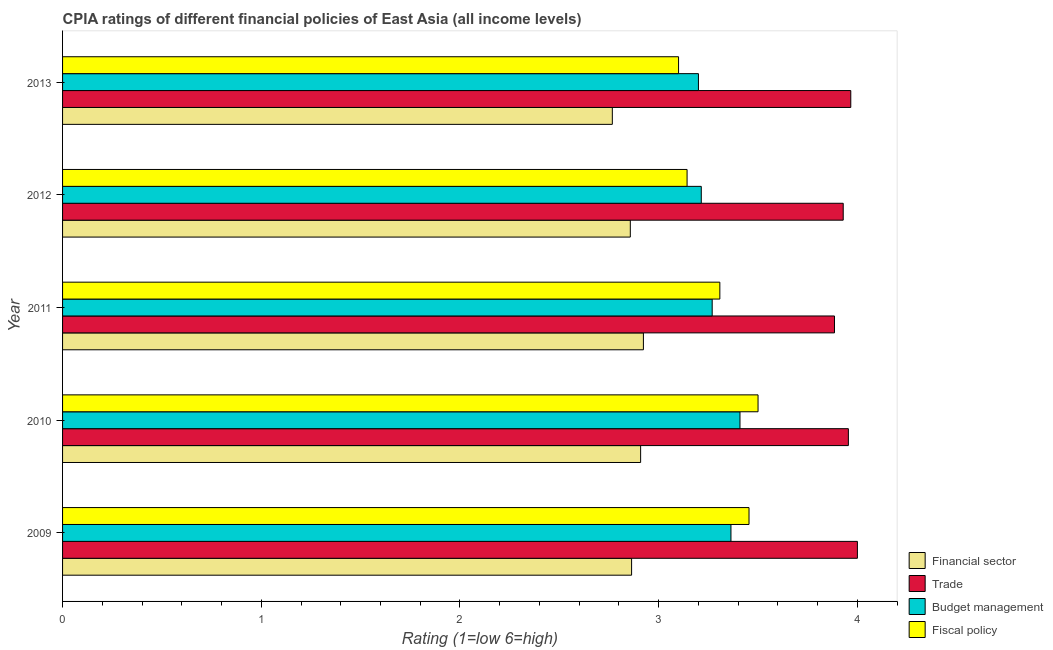How many different coloured bars are there?
Your response must be concise. 4. How many groups of bars are there?
Provide a short and direct response. 5. Are the number of bars on each tick of the Y-axis equal?
Your answer should be compact. Yes. How many bars are there on the 3rd tick from the top?
Your answer should be compact. 4. How many bars are there on the 5th tick from the bottom?
Provide a short and direct response. 4. In how many cases, is the number of bars for a given year not equal to the number of legend labels?
Keep it short and to the point. 0. What is the cpia rating of fiscal policy in 2013?
Make the answer very short. 3.1. Across all years, what is the maximum cpia rating of budget management?
Provide a short and direct response. 3.41. Across all years, what is the minimum cpia rating of trade?
Keep it short and to the point. 3.88. In which year was the cpia rating of fiscal policy maximum?
Ensure brevity in your answer.  2010. In which year was the cpia rating of trade minimum?
Provide a short and direct response. 2011. What is the total cpia rating of financial sector in the graph?
Offer a very short reply. 14.32. What is the difference between the cpia rating of financial sector in 2011 and that in 2013?
Keep it short and to the point. 0.16. What is the difference between the cpia rating of budget management in 2012 and the cpia rating of trade in 2011?
Provide a succinct answer. -0.67. What is the average cpia rating of fiscal policy per year?
Give a very brief answer. 3.3. In the year 2013, what is the difference between the cpia rating of budget management and cpia rating of fiscal policy?
Make the answer very short. 0.1. In how many years, is the cpia rating of fiscal policy greater than 2.6 ?
Provide a short and direct response. 5. What is the ratio of the cpia rating of fiscal policy in 2012 to that in 2013?
Ensure brevity in your answer.  1.01. Is the cpia rating of financial sector in 2012 less than that in 2013?
Keep it short and to the point. No. Is the difference between the cpia rating of financial sector in 2012 and 2013 greater than the difference between the cpia rating of fiscal policy in 2012 and 2013?
Provide a succinct answer. Yes. What is the difference between the highest and the second highest cpia rating of financial sector?
Provide a succinct answer. 0.01. What is the difference between the highest and the lowest cpia rating of fiscal policy?
Ensure brevity in your answer.  0.4. In how many years, is the cpia rating of budget management greater than the average cpia rating of budget management taken over all years?
Make the answer very short. 2. Is the sum of the cpia rating of fiscal policy in 2010 and 2012 greater than the maximum cpia rating of financial sector across all years?
Give a very brief answer. Yes. Is it the case that in every year, the sum of the cpia rating of trade and cpia rating of fiscal policy is greater than the sum of cpia rating of budget management and cpia rating of financial sector?
Provide a succinct answer. Yes. What does the 4th bar from the top in 2011 represents?
Keep it short and to the point. Financial sector. What does the 3rd bar from the bottom in 2012 represents?
Ensure brevity in your answer.  Budget management. Is it the case that in every year, the sum of the cpia rating of financial sector and cpia rating of trade is greater than the cpia rating of budget management?
Your answer should be compact. Yes. Are all the bars in the graph horizontal?
Provide a short and direct response. Yes. How many years are there in the graph?
Give a very brief answer. 5. Are the values on the major ticks of X-axis written in scientific E-notation?
Your answer should be very brief. No. Does the graph contain grids?
Give a very brief answer. No. Where does the legend appear in the graph?
Make the answer very short. Bottom right. How are the legend labels stacked?
Make the answer very short. Vertical. What is the title of the graph?
Keep it short and to the point. CPIA ratings of different financial policies of East Asia (all income levels). What is the label or title of the Y-axis?
Provide a short and direct response. Year. What is the Rating (1=low 6=high) in Financial sector in 2009?
Ensure brevity in your answer.  2.86. What is the Rating (1=low 6=high) of Budget management in 2009?
Keep it short and to the point. 3.36. What is the Rating (1=low 6=high) in Fiscal policy in 2009?
Make the answer very short. 3.45. What is the Rating (1=low 6=high) of Financial sector in 2010?
Give a very brief answer. 2.91. What is the Rating (1=low 6=high) of Trade in 2010?
Your answer should be compact. 3.95. What is the Rating (1=low 6=high) of Budget management in 2010?
Your answer should be very brief. 3.41. What is the Rating (1=low 6=high) in Fiscal policy in 2010?
Ensure brevity in your answer.  3.5. What is the Rating (1=low 6=high) of Financial sector in 2011?
Your answer should be very brief. 2.92. What is the Rating (1=low 6=high) in Trade in 2011?
Your answer should be very brief. 3.88. What is the Rating (1=low 6=high) of Budget management in 2011?
Give a very brief answer. 3.27. What is the Rating (1=low 6=high) in Fiscal policy in 2011?
Provide a succinct answer. 3.31. What is the Rating (1=low 6=high) of Financial sector in 2012?
Provide a succinct answer. 2.86. What is the Rating (1=low 6=high) of Trade in 2012?
Offer a terse response. 3.93. What is the Rating (1=low 6=high) of Budget management in 2012?
Give a very brief answer. 3.21. What is the Rating (1=low 6=high) in Fiscal policy in 2012?
Ensure brevity in your answer.  3.14. What is the Rating (1=low 6=high) of Financial sector in 2013?
Provide a short and direct response. 2.77. What is the Rating (1=low 6=high) in Trade in 2013?
Your response must be concise. 3.97. Across all years, what is the maximum Rating (1=low 6=high) of Financial sector?
Give a very brief answer. 2.92. Across all years, what is the maximum Rating (1=low 6=high) of Budget management?
Offer a terse response. 3.41. Across all years, what is the minimum Rating (1=low 6=high) in Financial sector?
Offer a terse response. 2.77. Across all years, what is the minimum Rating (1=low 6=high) of Trade?
Make the answer very short. 3.88. Across all years, what is the minimum Rating (1=low 6=high) in Budget management?
Provide a succinct answer. 3.2. What is the total Rating (1=low 6=high) in Financial sector in the graph?
Keep it short and to the point. 14.32. What is the total Rating (1=low 6=high) in Trade in the graph?
Make the answer very short. 19.73. What is the total Rating (1=low 6=high) of Budget management in the graph?
Ensure brevity in your answer.  16.46. What is the total Rating (1=low 6=high) in Fiscal policy in the graph?
Your answer should be very brief. 16.51. What is the difference between the Rating (1=low 6=high) in Financial sector in 2009 and that in 2010?
Make the answer very short. -0.05. What is the difference between the Rating (1=low 6=high) in Trade in 2009 and that in 2010?
Provide a short and direct response. 0.05. What is the difference between the Rating (1=low 6=high) of Budget management in 2009 and that in 2010?
Keep it short and to the point. -0.05. What is the difference between the Rating (1=low 6=high) of Fiscal policy in 2009 and that in 2010?
Ensure brevity in your answer.  -0.05. What is the difference between the Rating (1=low 6=high) in Financial sector in 2009 and that in 2011?
Your answer should be very brief. -0.06. What is the difference between the Rating (1=low 6=high) of Trade in 2009 and that in 2011?
Offer a very short reply. 0.12. What is the difference between the Rating (1=low 6=high) of Budget management in 2009 and that in 2011?
Make the answer very short. 0.09. What is the difference between the Rating (1=low 6=high) in Fiscal policy in 2009 and that in 2011?
Make the answer very short. 0.15. What is the difference between the Rating (1=low 6=high) in Financial sector in 2009 and that in 2012?
Ensure brevity in your answer.  0.01. What is the difference between the Rating (1=low 6=high) in Trade in 2009 and that in 2012?
Offer a terse response. 0.07. What is the difference between the Rating (1=low 6=high) of Budget management in 2009 and that in 2012?
Ensure brevity in your answer.  0.15. What is the difference between the Rating (1=low 6=high) of Fiscal policy in 2009 and that in 2012?
Your answer should be very brief. 0.31. What is the difference between the Rating (1=low 6=high) in Financial sector in 2009 and that in 2013?
Ensure brevity in your answer.  0.1. What is the difference between the Rating (1=low 6=high) of Trade in 2009 and that in 2013?
Provide a succinct answer. 0.03. What is the difference between the Rating (1=low 6=high) in Budget management in 2009 and that in 2013?
Make the answer very short. 0.16. What is the difference between the Rating (1=low 6=high) of Fiscal policy in 2009 and that in 2013?
Keep it short and to the point. 0.35. What is the difference between the Rating (1=low 6=high) in Financial sector in 2010 and that in 2011?
Your response must be concise. -0.01. What is the difference between the Rating (1=low 6=high) in Trade in 2010 and that in 2011?
Provide a succinct answer. 0.07. What is the difference between the Rating (1=low 6=high) in Budget management in 2010 and that in 2011?
Make the answer very short. 0.14. What is the difference between the Rating (1=low 6=high) of Fiscal policy in 2010 and that in 2011?
Keep it short and to the point. 0.19. What is the difference between the Rating (1=low 6=high) of Financial sector in 2010 and that in 2012?
Provide a succinct answer. 0.05. What is the difference between the Rating (1=low 6=high) in Trade in 2010 and that in 2012?
Offer a terse response. 0.03. What is the difference between the Rating (1=low 6=high) in Budget management in 2010 and that in 2012?
Ensure brevity in your answer.  0.19. What is the difference between the Rating (1=low 6=high) in Fiscal policy in 2010 and that in 2012?
Offer a terse response. 0.36. What is the difference between the Rating (1=low 6=high) in Financial sector in 2010 and that in 2013?
Offer a terse response. 0.14. What is the difference between the Rating (1=low 6=high) in Trade in 2010 and that in 2013?
Your answer should be very brief. -0.01. What is the difference between the Rating (1=low 6=high) in Budget management in 2010 and that in 2013?
Your answer should be compact. 0.21. What is the difference between the Rating (1=low 6=high) in Fiscal policy in 2010 and that in 2013?
Provide a short and direct response. 0.4. What is the difference between the Rating (1=low 6=high) of Financial sector in 2011 and that in 2012?
Offer a very short reply. 0.07. What is the difference between the Rating (1=low 6=high) of Trade in 2011 and that in 2012?
Your answer should be very brief. -0.04. What is the difference between the Rating (1=low 6=high) of Budget management in 2011 and that in 2012?
Your response must be concise. 0.05. What is the difference between the Rating (1=low 6=high) of Fiscal policy in 2011 and that in 2012?
Provide a short and direct response. 0.16. What is the difference between the Rating (1=low 6=high) in Financial sector in 2011 and that in 2013?
Give a very brief answer. 0.16. What is the difference between the Rating (1=low 6=high) of Trade in 2011 and that in 2013?
Your response must be concise. -0.08. What is the difference between the Rating (1=low 6=high) of Budget management in 2011 and that in 2013?
Offer a terse response. 0.07. What is the difference between the Rating (1=low 6=high) of Fiscal policy in 2011 and that in 2013?
Offer a very short reply. 0.21. What is the difference between the Rating (1=low 6=high) of Financial sector in 2012 and that in 2013?
Your response must be concise. 0.09. What is the difference between the Rating (1=low 6=high) of Trade in 2012 and that in 2013?
Your answer should be compact. -0.04. What is the difference between the Rating (1=low 6=high) in Budget management in 2012 and that in 2013?
Give a very brief answer. 0.01. What is the difference between the Rating (1=low 6=high) of Fiscal policy in 2012 and that in 2013?
Your answer should be compact. 0.04. What is the difference between the Rating (1=low 6=high) of Financial sector in 2009 and the Rating (1=low 6=high) of Trade in 2010?
Your answer should be compact. -1.09. What is the difference between the Rating (1=low 6=high) of Financial sector in 2009 and the Rating (1=low 6=high) of Budget management in 2010?
Provide a succinct answer. -0.55. What is the difference between the Rating (1=low 6=high) in Financial sector in 2009 and the Rating (1=low 6=high) in Fiscal policy in 2010?
Your response must be concise. -0.64. What is the difference between the Rating (1=low 6=high) of Trade in 2009 and the Rating (1=low 6=high) of Budget management in 2010?
Offer a very short reply. 0.59. What is the difference between the Rating (1=low 6=high) of Trade in 2009 and the Rating (1=low 6=high) of Fiscal policy in 2010?
Provide a succinct answer. 0.5. What is the difference between the Rating (1=low 6=high) of Budget management in 2009 and the Rating (1=low 6=high) of Fiscal policy in 2010?
Make the answer very short. -0.14. What is the difference between the Rating (1=low 6=high) of Financial sector in 2009 and the Rating (1=low 6=high) of Trade in 2011?
Offer a terse response. -1.02. What is the difference between the Rating (1=low 6=high) in Financial sector in 2009 and the Rating (1=low 6=high) in Budget management in 2011?
Offer a terse response. -0.41. What is the difference between the Rating (1=low 6=high) of Financial sector in 2009 and the Rating (1=low 6=high) of Fiscal policy in 2011?
Offer a very short reply. -0.44. What is the difference between the Rating (1=low 6=high) of Trade in 2009 and the Rating (1=low 6=high) of Budget management in 2011?
Keep it short and to the point. 0.73. What is the difference between the Rating (1=low 6=high) in Trade in 2009 and the Rating (1=low 6=high) in Fiscal policy in 2011?
Your response must be concise. 0.69. What is the difference between the Rating (1=low 6=high) in Budget management in 2009 and the Rating (1=low 6=high) in Fiscal policy in 2011?
Make the answer very short. 0.06. What is the difference between the Rating (1=low 6=high) in Financial sector in 2009 and the Rating (1=low 6=high) in Trade in 2012?
Offer a terse response. -1.06. What is the difference between the Rating (1=low 6=high) of Financial sector in 2009 and the Rating (1=low 6=high) of Budget management in 2012?
Keep it short and to the point. -0.35. What is the difference between the Rating (1=low 6=high) in Financial sector in 2009 and the Rating (1=low 6=high) in Fiscal policy in 2012?
Your answer should be very brief. -0.28. What is the difference between the Rating (1=low 6=high) of Trade in 2009 and the Rating (1=low 6=high) of Budget management in 2012?
Your answer should be very brief. 0.79. What is the difference between the Rating (1=low 6=high) of Budget management in 2009 and the Rating (1=low 6=high) of Fiscal policy in 2012?
Give a very brief answer. 0.22. What is the difference between the Rating (1=low 6=high) of Financial sector in 2009 and the Rating (1=low 6=high) of Trade in 2013?
Provide a short and direct response. -1.1. What is the difference between the Rating (1=low 6=high) of Financial sector in 2009 and the Rating (1=low 6=high) of Budget management in 2013?
Your response must be concise. -0.34. What is the difference between the Rating (1=low 6=high) of Financial sector in 2009 and the Rating (1=low 6=high) of Fiscal policy in 2013?
Your answer should be compact. -0.24. What is the difference between the Rating (1=low 6=high) of Budget management in 2009 and the Rating (1=low 6=high) of Fiscal policy in 2013?
Provide a short and direct response. 0.26. What is the difference between the Rating (1=low 6=high) in Financial sector in 2010 and the Rating (1=low 6=high) in Trade in 2011?
Your response must be concise. -0.98. What is the difference between the Rating (1=low 6=high) of Financial sector in 2010 and the Rating (1=low 6=high) of Budget management in 2011?
Keep it short and to the point. -0.36. What is the difference between the Rating (1=low 6=high) of Financial sector in 2010 and the Rating (1=low 6=high) of Fiscal policy in 2011?
Offer a very short reply. -0.4. What is the difference between the Rating (1=low 6=high) of Trade in 2010 and the Rating (1=low 6=high) of Budget management in 2011?
Provide a succinct answer. 0.69. What is the difference between the Rating (1=low 6=high) in Trade in 2010 and the Rating (1=low 6=high) in Fiscal policy in 2011?
Provide a short and direct response. 0.65. What is the difference between the Rating (1=low 6=high) of Budget management in 2010 and the Rating (1=low 6=high) of Fiscal policy in 2011?
Provide a succinct answer. 0.1. What is the difference between the Rating (1=low 6=high) in Financial sector in 2010 and the Rating (1=low 6=high) in Trade in 2012?
Give a very brief answer. -1.02. What is the difference between the Rating (1=low 6=high) of Financial sector in 2010 and the Rating (1=low 6=high) of Budget management in 2012?
Your answer should be compact. -0.31. What is the difference between the Rating (1=low 6=high) in Financial sector in 2010 and the Rating (1=low 6=high) in Fiscal policy in 2012?
Keep it short and to the point. -0.23. What is the difference between the Rating (1=low 6=high) of Trade in 2010 and the Rating (1=low 6=high) of Budget management in 2012?
Your response must be concise. 0.74. What is the difference between the Rating (1=low 6=high) of Trade in 2010 and the Rating (1=low 6=high) of Fiscal policy in 2012?
Offer a terse response. 0.81. What is the difference between the Rating (1=low 6=high) of Budget management in 2010 and the Rating (1=low 6=high) of Fiscal policy in 2012?
Make the answer very short. 0.27. What is the difference between the Rating (1=low 6=high) of Financial sector in 2010 and the Rating (1=low 6=high) of Trade in 2013?
Keep it short and to the point. -1.06. What is the difference between the Rating (1=low 6=high) in Financial sector in 2010 and the Rating (1=low 6=high) in Budget management in 2013?
Give a very brief answer. -0.29. What is the difference between the Rating (1=low 6=high) in Financial sector in 2010 and the Rating (1=low 6=high) in Fiscal policy in 2013?
Make the answer very short. -0.19. What is the difference between the Rating (1=low 6=high) in Trade in 2010 and the Rating (1=low 6=high) in Budget management in 2013?
Ensure brevity in your answer.  0.75. What is the difference between the Rating (1=low 6=high) in Trade in 2010 and the Rating (1=low 6=high) in Fiscal policy in 2013?
Your answer should be very brief. 0.85. What is the difference between the Rating (1=low 6=high) in Budget management in 2010 and the Rating (1=low 6=high) in Fiscal policy in 2013?
Your answer should be compact. 0.31. What is the difference between the Rating (1=low 6=high) in Financial sector in 2011 and the Rating (1=low 6=high) in Trade in 2012?
Offer a very short reply. -1.01. What is the difference between the Rating (1=low 6=high) in Financial sector in 2011 and the Rating (1=low 6=high) in Budget management in 2012?
Keep it short and to the point. -0.29. What is the difference between the Rating (1=low 6=high) of Financial sector in 2011 and the Rating (1=low 6=high) of Fiscal policy in 2012?
Offer a terse response. -0.22. What is the difference between the Rating (1=low 6=high) of Trade in 2011 and the Rating (1=low 6=high) of Budget management in 2012?
Ensure brevity in your answer.  0.67. What is the difference between the Rating (1=low 6=high) of Trade in 2011 and the Rating (1=low 6=high) of Fiscal policy in 2012?
Provide a short and direct response. 0.74. What is the difference between the Rating (1=low 6=high) in Budget management in 2011 and the Rating (1=low 6=high) in Fiscal policy in 2012?
Ensure brevity in your answer.  0.13. What is the difference between the Rating (1=low 6=high) in Financial sector in 2011 and the Rating (1=low 6=high) in Trade in 2013?
Your answer should be compact. -1.04. What is the difference between the Rating (1=low 6=high) of Financial sector in 2011 and the Rating (1=low 6=high) of Budget management in 2013?
Your answer should be compact. -0.28. What is the difference between the Rating (1=low 6=high) in Financial sector in 2011 and the Rating (1=low 6=high) in Fiscal policy in 2013?
Your answer should be very brief. -0.18. What is the difference between the Rating (1=low 6=high) in Trade in 2011 and the Rating (1=low 6=high) in Budget management in 2013?
Give a very brief answer. 0.68. What is the difference between the Rating (1=low 6=high) of Trade in 2011 and the Rating (1=low 6=high) of Fiscal policy in 2013?
Give a very brief answer. 0.78. What is the difference between the Rating (1=low 6=high) in Budget management in 2011 and the Rating (1=low 6=high) in Fiscal policy in 2013?
Give a very brief answer. 0.17. What is the difference between the Rating (1=low 6=high) in Financial sector in 2012 and the Rating (1=low 6=high) in Trade in 2013?
Provide a short and direct response. -1.11. What is the difference between the Rating (1=low 6=high) of Financial sector in 2012 and the Rating (1=low 6=high) of Budget management in 2013?
Ensure brevity in your answer.  -0.34. What is the difference between the Rating (1=low 6=high) of Financial sector in 2012 and the Rating (1=low 6=high) of Fiscal policy in 2013?
Your answer should be compact. -0.24. What is the difference between the Rating (1=low 6=high) of Trade in 2012 and the Rating (1=low 6=high) of Budget management in 2013?
Ensure brevity in your answer.  0.73. What is the difference between the Rating (1=low 6=high) of Trade in 2012 and the Rating (1=low 6=high) of Fiscal policy in 2013?
Give a very brief answer. 0.83. What is the difference between the Rating (1=low 6=high) of Budget management in 2012 and the Rating (1=low 6=high) of Fiscal policy in 2013?
Your answer should be very brief. 0.11. What is the average Rating (1=low 6=high) of Financial sector per year?
Give a very brief answer. 2.86. What is the average Rating (1=low 6=high) of Trade per year?
Your answer should be very brief. 3.95. What is the average Rating (1=low 6=high) of Budget management per year?
Your answer should be compact. 3.29. What is the average Rating (1=low 6=high) of Fiscal policy per year?
Offer a terse response. 3.3. In the year 2009, what is the difference between the Rating (1=low 6=high) of Financial sector and Rating (1=low 6=high) of Trade?
Offer a very short reply. -1.14. In the year 2009, what is the difference between the Rating (1=low 6=high) of Financial sector and Rating (1=low 6=high) of Budget management?
Give a very brief answer. -0.5. In the year 2009, what is the difference between the Rating (1=low 6=high) of Financial sector and Rating (1=low 6=high) of Fiscal policy?
Provide a succinct answer. -0.59. In the year 2009, what is the difference between the Rating (1=low 6=high) of Trade and Rating (1=low 6=high) of Budget management?
Your answer should be very brief. 0.64. In the year 2009, what is the difference between the Rating (1=low 6=high) of Trade and Rating (1=low 6=high) of Fiscal policy?
Keep it short and to the point. 0.55. In the year 2009, what is the difference between the Rating (1=low 6=high) of Budget management and Rating (1=low 6=high) of Fiscal policy?
Provide a succinct answer. -0.09. In the year 2010, what is the difference between the Rating (1=low 6=high) in Financial sector and Rating (1=low 6=high) in Trade?
Offer a terse response. -1.05. In the year 2010, what is the difference between the Rating (1=low 6=high) of Financial sector and Rating (1=low 6=high) of Fiscal policy?
Offer a very short reply. -0.59. In the year 2010, what is the difference between the Rating (1=low 6=high) of Trade and Rating (1=low 6=high) of Budget management?
Give a very brief answer. 0.55. In the year 2010, what is the difference between the Rating (1=low 6=high) of Trade and Rating (1=low 6=high) of Fiscal policy?
Your answer should be very brief. 0.45. In the year 2010, what is the difference between the Rating (1=low 6=high) in Budget management and Rating (1=low 6=high) in Fiscal policy?
Your answer should be very brief. -0.09. In the year 2011, what is the difference between the Rating (1=low 6=high) of Financial sector and Rating (1=low 6=high) of Trade?
Provide a short and direct response. -0.96. In the year 2011, what is the difference between the Rating (1=low 6=high) in Financial sector and Rating (1=low 6=high) in Budget management?
Keep it short and to the point. -0.35. In the year 2011, what is the difference between the Rating (1=low 6=high) in Financial sector and Rating (1=low 6=high) in Fiscal policy?
Keep it short and to the point. -0.38. In the year 2011, what is the difference between the Rating (1=low 6=high) in Trade and Rating (1=low 6=high) in Budget management?
Make the answer very short. 0.62. In the year 2011, what is the difference between the Rating (1=low 6=high) in Trade and Rating (1=low 6=high) in Fiscal policy?
Ensure brevity in your answer.  0.58. In the year 2011, what is the difference between the Rating (1=low 6=high) of Budget management and Rating (1=low 6=high) of Fiscal policy?
Your answer should be compact. -0.04. In the year 2012, what is the difference between the Rating (1=low 6=high) of Financial sector and Rating (1=low 6=high) of Trade?
Your response must be concise. -1.07. In the year 2012, what is the difference between the Rating (1=low 6=high) of Financial sector and Rating (1=low 6=high) of Budget management?
Your response must be concise. -0.36. In the year 2012, what is the difference between the Rating (1=low 6=high) of Financial sector and Rating (1=low 6=high) of Fiscal policy?
Your answer should be compact. -0.29. In the year 2012, what is the difference between the Rating (1=low 6=high) of Trade and Rating (1=low 6=high) of Fiscal policy?
Your response must be concise. 0.79. In the year 2012, what is the difference between the Rating (1=low 6=high) in Budget management and Rating (1=low 6=high) in Fiscal policy?
Give a very brief answer. 0.07. In the year 2013, what is the difference between the Rating (1=low 6=high) of Financial sector and Rating (1=low 6=high) of Trade?
Your answer should be very brief. -1.2. In the year 2013, what is the difference between the Rating (1=low 6=high) in Financial sector and Rating (1=low 6=high) in Budget management?
Your answer should be compact. -0.43. In the year 2013, what is the difference between the Rating (1=low 6=high) in Trade and Rating (1=low 6=high) in Budget management?
Keep it short and to the point. 0.77. In the year 2013, what is the difference between the Rating (1=low 6=high) of Trade and Rating (1=low 6=high) of Fiscal policy?
Your answer should be compact. 0.87. What is the ratio of the Rating (1=low 6=high) of Financial sector in 2009 to that in 2010?
Give a very brief answer. 0.98. What is the ratio of the Rating (1=low 6=high) in Trade in 2009 to that in 2010?
Your answer should be very brief. 1.01. What is the ratio of the Rating (1=low 6=high) in Budget management in 2009 to that in 2010?
Provide a succinct answer. 0.99. What is the ratio of the Rating (1=low 6=high) in Financial sector in 2009 to that in 2011?
Your response must be concise. 0.98. What is the ratio of the Rating (1=low 6=high) in Trade in 2009 to that in 2011?
Keep it short and to the point. 1.03. What is the ratio of the Rating (1=low 6=high) of Budget management in 2009 to that in 2011?
Provide a short and direct response. 1.03. What is the ratio of the Rating (1=low 6=high) of Fiscal policy in 2009 to that in 2011?
Your answer should be compact. 1.04. What is the ratio of the Rating (1=low 6=high) in Financial sector in 2009 to that in 2012?
Your answer should be very brief. 1. What is the ratio of the Rating (1=low 6=high) of Trade in 2009 to that in 2012?
Ensure brevity in your answer.  1.02. What is the ratio of the Rating (1=low 6=high) in Budget management in 2009 to that in 2012?
Make the answer very short. 1.05. What is the ratio of the Rating (1=low 6=high) of Fiscal policy in 2009 to that in 2012?
Provide a short and direct response. 1.1. What is the ratio of the Rating (1=low 6=high) of Financial sector in 2009 to that in 2013?
Offer a very short reply. 1.03. What is the ratio of the Rating (1=low 6=high) of Trade in 2009 to that in 2013?
Offer a very short reply. 1.01. What is the ratio of the Rating (1=low 6=high) of Budget management in 2009 to that in 2013?
Keep it short and to the point. 1.05. What is the ratio of the Rating (1=low 6=high) of Fiscal policy in 2009 to that in 2013?
Keep it short and to the point. 1.11. What is the ratio of the Rating (1=low 6=high) of Budget management in 2010 to that in 2011?
Offer a very short reply. 1.04. What is the ratio of the Rating (1=low 6=high) of Fiscal policy in 2010 to that in 2011?
Your answer should be very brief. 1.06. What is the ratio of the Rating (1=low 6=high) of Financial sector in 2010 to that in 2012?
Your answer should be compact. 1.02. What is the ratio of the Rating (1=low 6=high) of Trade in 2010 to that in 2012?
Your answer should be very brief. 1.01. What is the ratio of the Rating (1=low 6=high) of Budget management in 2010 to that in 2012?
Provide a succinct answer. 1.06. What is the ratio of the Rating (1=low 6=high) of Fiscal policy in 2010 to that in 2012?
Ensure brevity in your answer.  1.11. What is the ratio of the Rating (1=low 6=high) of Financial sector in 2010 to that in 2013?
Offer a very short reply. 1.05. What is the ratio of the Rating (1=low 6=high) in Trade in 2010 to that in 2013?
Provide a short and direct response. 1. What is the ratio of the Rating (1=low 6=high) in Budget management in 2010 to that in 2013?
Keep it short and to the point. 1.07. What is the ratio of the Rating (1=low 6=high) of Fiscal policy in 2010 to that in 2013?
Your answer should be very brief. 1.13. What is the ratio of the Rating (1=low 6=high) in Financial sector in 2011 to that in 2012?
Your response must be concise. 1.02. What is the ratio of the Rating (1=low 6=high) of Budget management in 2011 to that in 2012?
Offer a very short reply. 1.02. What is the ratio of the Rating (1=low 6=high) in Fiscal policy in 2011 to that in 2012?
Ensure brevity in your answer.  1.05. What is the ratio of the Rating (1=low 6=high) in Financial sector in 2011 to that in 2013?
Make the answer very short. 1.06. What is the ratio of the Rating (1=low 6=high) of Trade in 2011 to that in 2013?
Ensure brevity in your answer.  0.98. What is the ratio of the Rating (1=low 6=high) in Budget management in 2011 to that in 2013?
Offer a very short reply. 1.02. What is the ratio of the Rating (1=low 6=high) of Fiscal policy in 2011 to that in 2013?
Make the answer very short. 1.07. What is the ratio of the Rating (1=low 6=high) in Financial sector in 2012 to that in 2013?
Offer a very short reply. 1.03. What is the ratio of the Rating (1=low 6=high) in Trade in 2012 to that in 2013?
Keep it short and to the point. 0.99. What is the ratio of the Rating (1=low 6=high) in Fiscal policy in 2012 to that in 2013?
Provide a short and direct response. 1.01. What is the difference between the highest and the second highest Rating (1=low 6=high) in Financial sector?
Your answer should be very brief. 0.01. What is the difference between the highest and the second highest Rating (1=low 6=high) of Trade?
Give a very brief answer. 0.03. What is the difference between the highest and the second highest Rating (1=low 6=high) in Budget management?
Give a very brief answer. 0.05. What is the difference between the highest and the second highest Rating (1=low 6=high) in Fiscal policy?
Give a very brief answer. 0.05. What is the difference between the highest and the lowest Rating (1=low 6=high) in Financial sector?
Give a very brief answer. 0.16. What is the difference between the highest and the lowest Rating (1=low 6=high) of Trade?
Your answer should be compact. 0.12. What is the difference between the highest and the lowest Rating (1=low 6=high) in Budget management?
Provide a succinct answer. 0.21. 